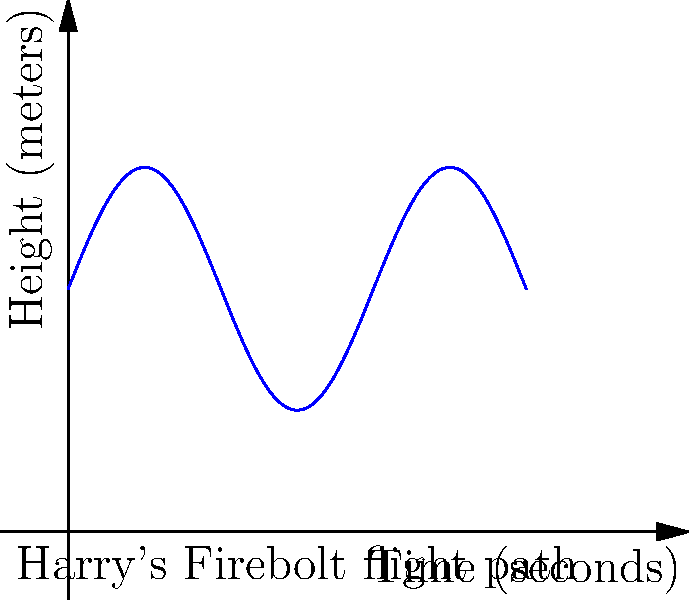During a thrilling Quidditch match, Harry Potter's Firebolt broom follows a sinusoidal path represented by the function $h(t) = 5\sin(\frac{t}{2}) + 10$, where $h$ is the height in meters and $t$ is the time in seconds. Calculate the total distance traveled by Harry in the vertical direction during the first 12 seconds of flight. To find the total vertical distance traveled, we need to calculate the definite integral of the absolute value of the derivative of $h(t)$ from $t=0$ to $t=12$. Let's break this down step-by-step:

1) First, find the derivative of $h(t)$:
   $h'(t) = 5 \cdot \frac{1}{2} \cos(\frac{t}{2}) = \frac{5}{2} \cos(\frac{t}{2})$

2) The total vertical distance is given by:
   $\int_0^{12} |h'(t)| dt = \int_0^{12} |\frac{5}{2} \cos(\frac{t}{2})| dt$

3) To solve this, we need to split the integral at the points where $\cos(\frac{t}{2})$ changes sign:
   $\cos(\frac{t}{2}) = 0$ when $\frac{t}{2} = \frac{\pi}{2}, \frac{3\pi}{2}$
   $t = \pi, 3\pi$

4) Split the integral:
   $\int_0^{\pi} \frac{5}{2} \cos(\frac{t}{2}) dt - \int_{\pi}^{3\pi} \frac{5}{2} \cos(\frac{t}{2}) dt + \int_{3\pi}^{12} \frac{5}{2} \cos(\frac{t}{2}) dt$

5) Evaluate each integral:
   $[5 \sin(\frac{t}{2})]_0^{\pi} - [5 \sin(\frac{t}{2})]_{\pi}^{3\pi} + [5 \sin(\frac{t}{2})]_{3\pi}^{12}$
   $= (5-0) - (0+5) + (5\sin(6)-0)$
   $= 5 - 5 + 5\sin(6)$
   $= 5\sin(6) \approx 1.45$ meters

Therefore, Harry's Firebolt travels approximately 1.45 meters vertically during the first 12 seconds of flight.
Answer: 1.45 meters 